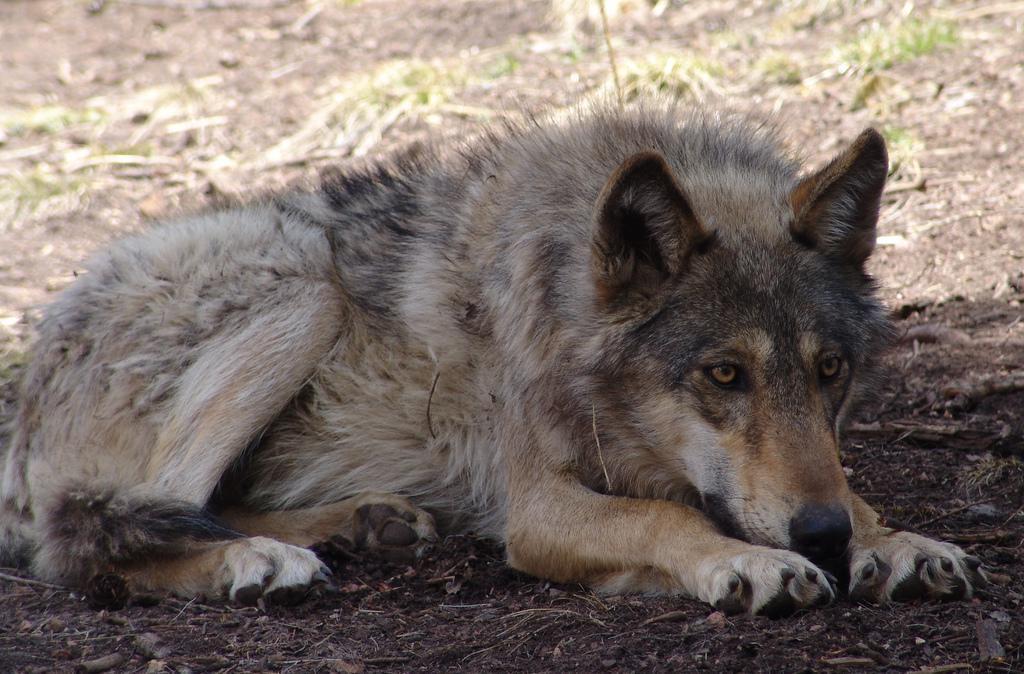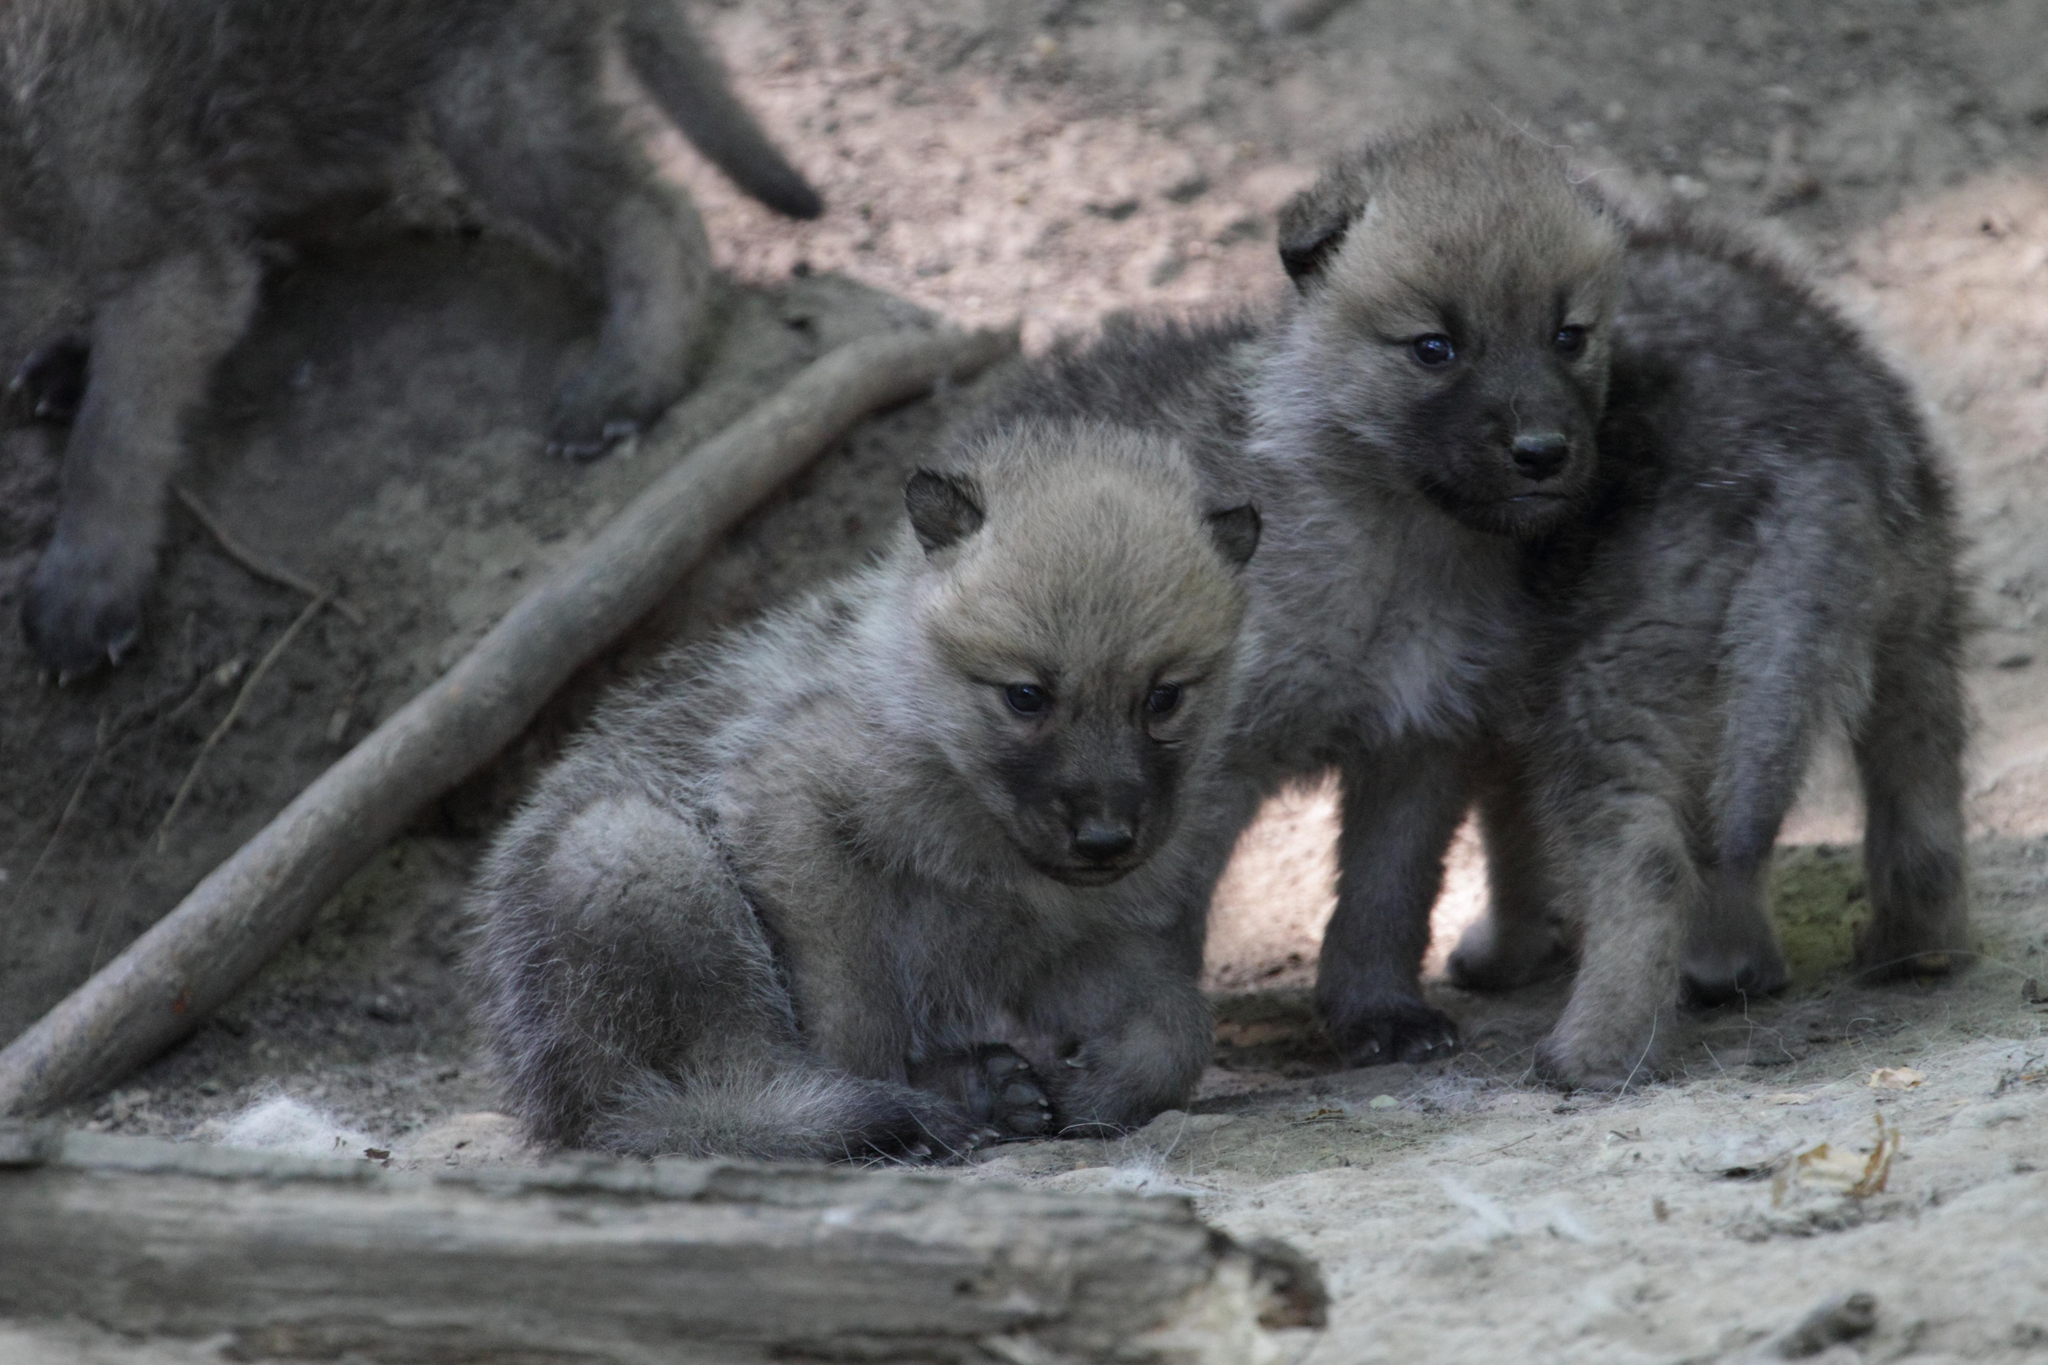The first image is the image on the left, the second image is the image on the right. Evaluate the accuracy of this statement regarding the images: "One of the images features a single animal.". Is it true? Answer yes or no. Yes. 